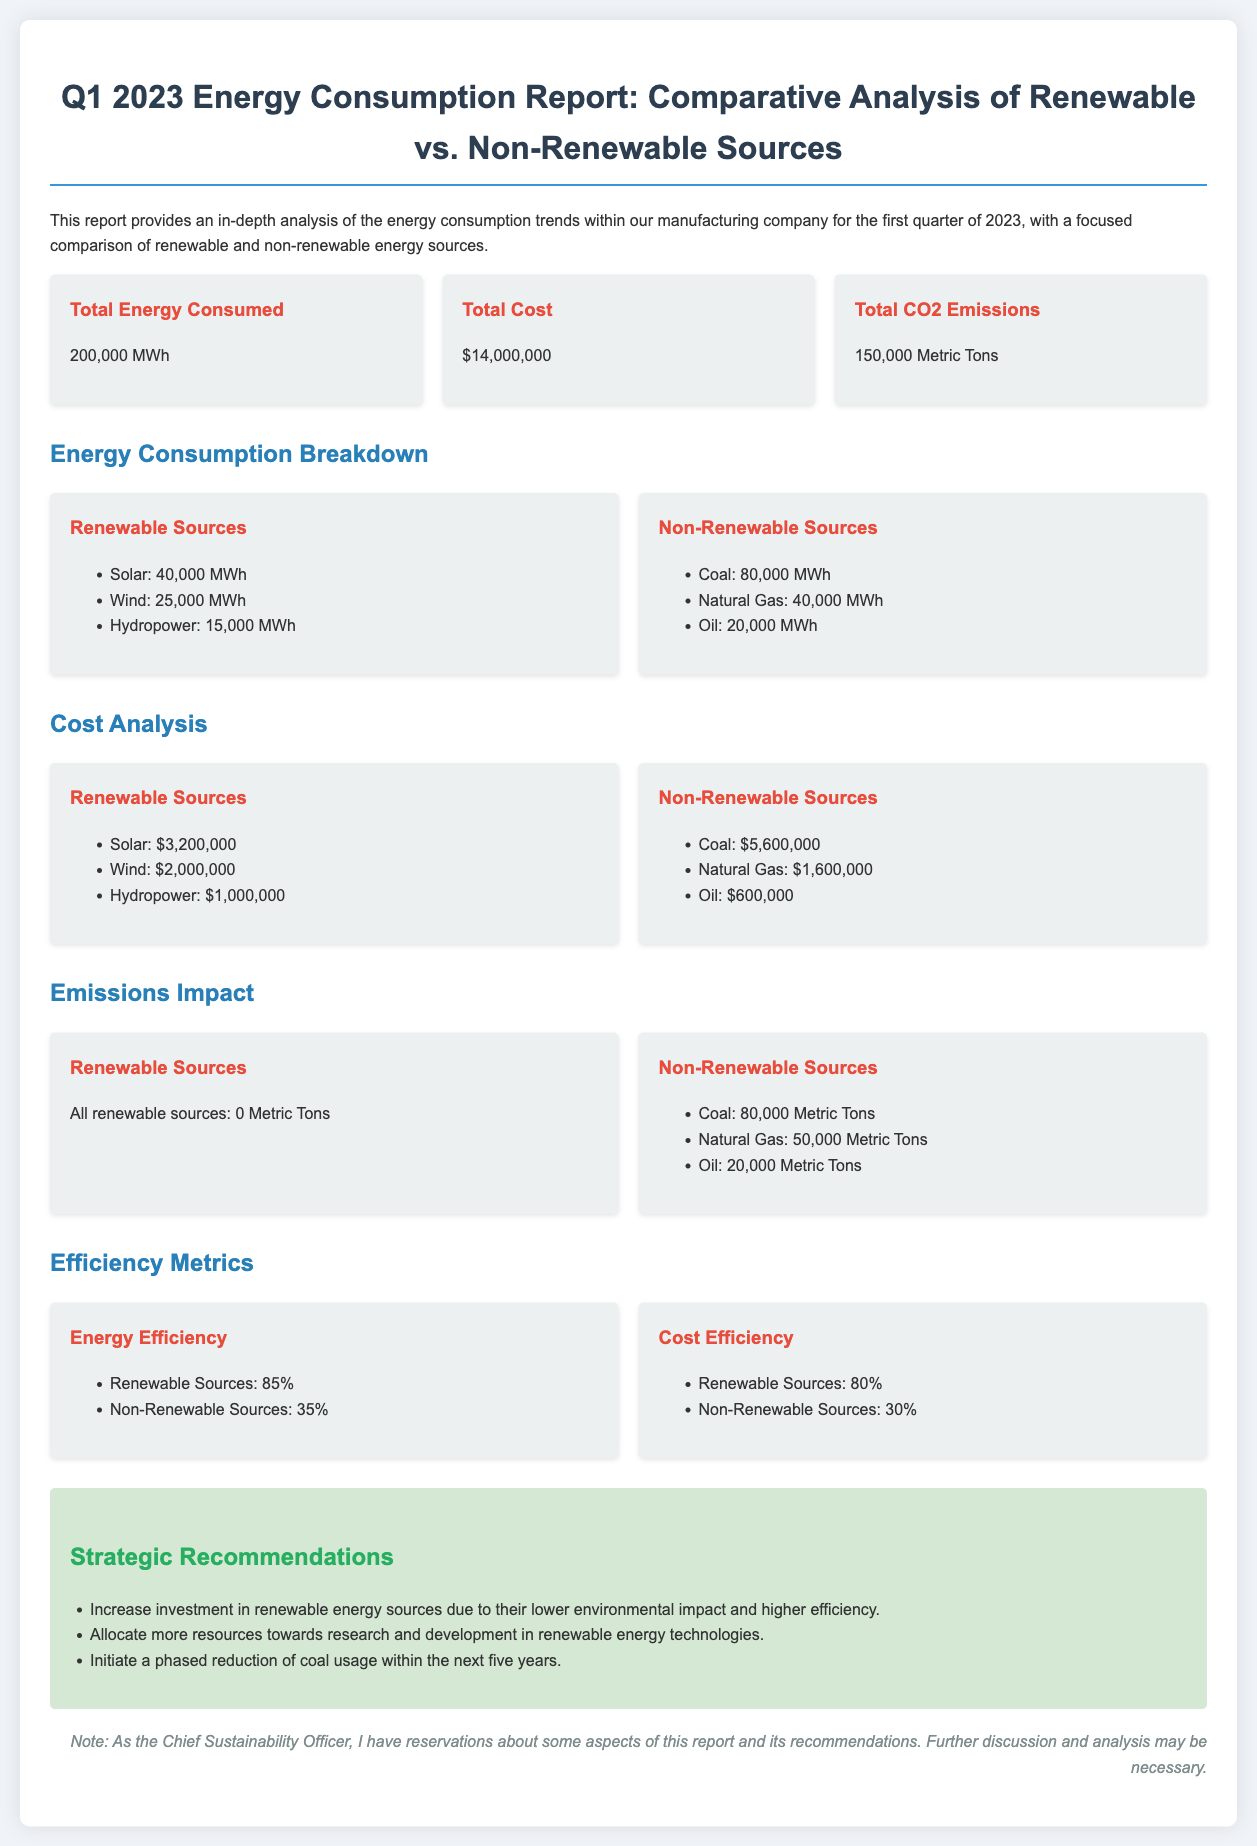what is the total energy consumed? The total energy consumed is stated in the report, which is 200,000 MWh.
Answer: 200,000 MWh what is the total cost? The total cost is specified in the report as $14,000,000.
Answer: $14,000,000 how much energy is consumed from solar sources? The energy consumed from solar sources is detailed, which is 40,000 MWh.
Answer: 40,000 MWh what is the CO2 emissions from non-renewable sources? The report mentions CO2 emissions from non-renewable sources as follows: Coal 80,000 Metric Tons, Natural Gas 50,000 Metric Tons, Oil 20,000 Metric Tons. The total is calculated as 150,000 Metric Tons.
Answer: 150,000 Metric Tons which energy sources are more efficient? The efficiency metrics are provided, showing that Renewable Sources have an efficiency of 85% and Non-Renewable Sources have 35%.
Answer: Renewable Sources how much does coal cost? The cost of coal is explicitly listed as $5,600,000.
Answer: $5,600,000 what are the strategic recommendations for energy consumption? The recommendations suggest increasing investment in renewable energy, allocating resources to research, and reducing coal usage.
Answer: Increase investment in renewable energy sources how much CO2 do renewable energy sources emit? The document states that all renewable sources emit 0 Metric Tons of CO2.
Answer: 0 Metric Tons what is the efficiency of non-renewable sources? The efficiency of non-renewable sources is specified as 35%.
Answer: 35% 